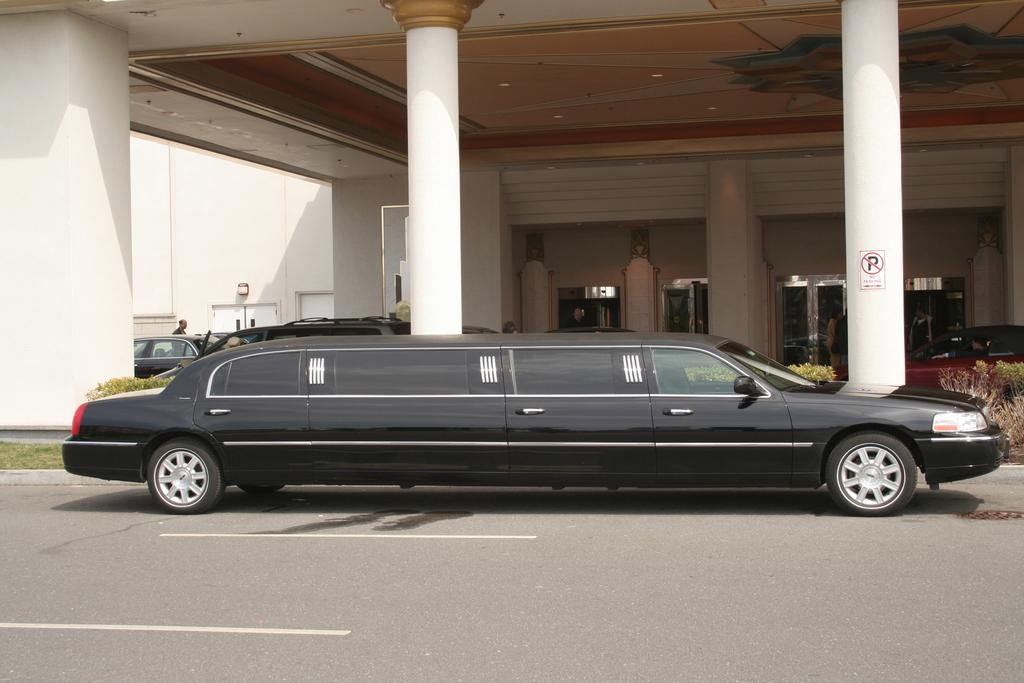What color is the car in the image? The car in the image is black. Where is the car located in relation to the hotel? The car is parked in front of a hotel. What architectural feature can be seen on the hotel? The hotel has big pillars. What rule does the car's friend break in the image? There is no indication of a car's friend or any rules being broken in the image. 